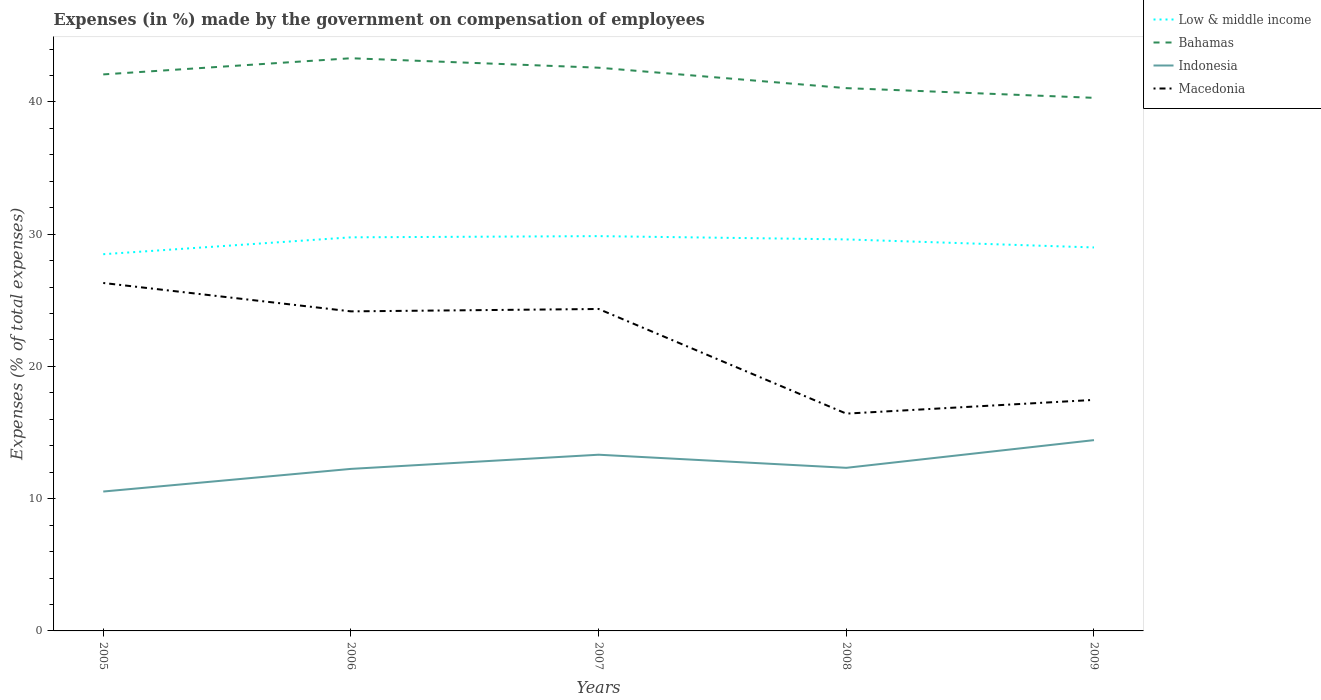How many different coloured lines are there?
Provide a short and direct response. 4. Does the line corresponding to Bahamas intersect with the line corresponding to Low & middle income?
Provide a short and direct response. No. Across all years, what is the maximum percentage of expenses made by the government on compensation of employees in Indonesia?
Provide a succinct answer. 10.54. In which year was the percentage of expenses made by the government on compensation of employees in Indonesia maximum?
Your response must be concise. 2005. What is the total percentage of expenses made by the government on compensation of employees in Macedonia in the graph?
Keep it short and to the point. 7.73. What is the difference between the highest and the second highest percentage of expenses made by the government on compensation of employees in Bahamas?
Provide a succinct answer. 2.99. What is the difference between the highest and the lowest percentage of expenses made by the government on compensation of employees in Low & middle income?
Provide a short and direct response. 3. Is the percentage of expenses made by the government on compensation of employees in Low & middle income strictly greater than the percentage of expenses made by the government on compensation of employees in Indonesia over the years?
Your answer should be compact. No. What is the difference between two consecutive major ticks on the Y-axis?
Keep it short and to the point. 10. Are the values on the major ticks of Y-axis written in scientific E-notation?
Offer a terse response. No. Where does the legend appear in the graph?
Provide a succinct answer. Top right. How many legend labels are there?
Your answer should be compact. 4. How are the legend labels stacked?
Provide a succinct answer. Vertical. What is the title of the graph?
Make the answer very short. Expenses (in %) made by the government on compensation of employees. Does "Paraguay" appear as one of the legend labels in the graph?
Your answer should be very brief. No. What is the label or title of the Y-axis?
Provide a short and direct response. Expenses (% of total expenses). What is the Expenses (% of total expenses) in Low & middle income in 2005?
Your response must be concise. 28.48. What is the Expenses (% of total expenses) in Bahamas in 2005?
Give a very brief answer. 42.08. What is the Expenses (% of total expenses) of Indonesia in 2005?
Keep it short and to the point. 10.54. What is the Expenses (% of total expenses) in Macedonia in 2005?
Offer a very short reply. 26.31. What is the Expenses (% of total expenses) of Low & middle income in 2006?
Give a very brief answer. 29.76. What is the Expenses (% of total expenses) of Bahamas in 2006?
Offer a terse response. 43.3. What is the Expenses (% of total expenses) in Indonesia in 2006?
Make the answer very short. 12.25. What is the Expenses (% of total expenses) in Macedonia in 2006?
Your response must be concise. 24.16. What is the Expenses (% of total expenses) in Low & middle income in 2007?
Ensure brevity in your answer.  29.85. What is the Expenses (% of total expenses) of Bahamas in 2007?
Your response must be concise. 42.59. What is the Expenses (% of total expenses) of Indonesia in 2007?
Ensure brevity in your answer.  13.32. What is the Expenses (% of total expenses) of Macedonia in 2007?
Offer a very short reply. 24.34. What is the Expenses (% of total expenses) of Low & middle income in 2008?
Your answer should be very brief. 29.6. What is the Expenses (% of total expenses) of Bahamas in 2008?
Give a very brief answer. 41.04. What is the Expenses (% of total expenses) of Indonesia in 2008?
Provide a short and direct response. 12.33. What is the Expenses (% of total expenses) in Macedonia in 2008?
Make the answer very short. 16.43. What is the Expenses (% of total expenses) of Low & middle income in 2009?
Keep it short and to the point. 29. What is the Expenses (% of total expenses) of Bahamas in 2009?
Ensure brevity in your answer.  40.31. What is the Expenses (% of total expenses) in Indonesia in 2009?
Offer a terse response. 14.43. What is the Expenses (% of total expenses) of Macedonia in 2009?
Ensure brevity in your answer.  17.47. Across all years, what is the maximum Expenses (% of total expenses) of Low & middle income?
Provide a succinct answer. 29.85. Across all years, what is the maximum Expenses (% of total expenses) of Bahamas?
Keep it short and to the point. 43.3. Across all years, what is the maximum Expenses (% of total expenses) in Indonesia?
Your answer should be compact. 14.43. Across all years, what is the maximum Expenses (% of total expenses) in Macedonia?
Your answer should be very brief. 26.31. Across all years, what is the minimum Expenses (% of total expenses) in Low & middle income?
Your response must be concise. 28.48. Across all years, what is the minimum Expenses (% of total expenses) of Bahamas?
Ensure brevity in your answer.  40.31. Across all years, what is the minimum Expenses (% of total expenses) in Indonesia?
Offer a very short reply. 10.54. Across all years, what is the minimum Expenses (% of total expenses) of Macedonia?
Your response must be concise. 16.43. What is the total Expenses (% of total expenses) of Low & middle income in the graph?
Offer a very short reply. 146.7. What is the total Expenses (% of total expenses) in Bahamas in the graph?
Make the answer very short. 209.32. What is the total Expenses (% of total expenses) of Indonesia in the graph?
Provide a succinct answer. 62.87. What is the total Expenses (% of total expenses) of Macedonia in the graph?
Make the answer very short. 108.72. What is the difference between the Expenses (% of total expenses) in Low & middle income in 2005 and that in 2006?
Provide a succinct answer. -1.28. What is the difference between the Expenses (% of total expenses) of Bahamas in 2005 and that in 2006?
Keep it short and to the point. -1.22. What is the difference between the Expenses (% of total expenses) of Indonesia in 2005 and that in 2006?
Your answer should be very brief. -1.71. What is the difference between the Expenses (% of total expenses) in Macedonia in 2005 and that in 2006?
Make the answer very short. 2.15. What is the difference between the Expenses (% of total expenses) of Low & middle income in 2005 and that in 2007?
Your answer should be compact. -1.37. What is the difference between the Expenses (% of total expenses) of Bahamas in 2005 and that in 2007?
Make the answer very short. -0.51. What is the difference between the Expenses (% of total expenses) in Indonesia in 2005 and that in 2007?
Keep it short and to the point. -2.78. What is the difference between the Expenses (% of total expenses) in Macedonia in 2005 and that in 2007?
Offer a very short reply. 1.97. What is the difference between the Expenses (% of total expenses) in Low & middle income in 2005 and that in 2008?
Provide a short and direct response. -1.12. What is the difference between the Expenses (% of total expenses) of Bahamas in 2005 and that in 2008?
Provide a short and direct response. 1.04. What is the difference between the Expenses (% of total expenses) in Indonesia in 2005 and that in 2008?
Your answer should be very brief. -1.79. What is the difference between the Expenses (% of total expenses) of Macedonia in 2005 and that in 2008?
Offer a terse response. 9.88. What is the difference between the Expenses (% of total expenses) in Low & middle income in 2005 and that in 2009?
Provide a succinct answer. -0.51. What is the difference between the Expenses (% of total expenses) in Bahamas in 2005 and that in 2009?
Keep it short and to the point. 1.77. What is the difference between the Expenses (% of total expenses) of Indonesia in 2005 and that in 2009?
Offer a very short reply. -3.89. What is the difference between the Expenses (% of total expenses) in Macedonia in 2005 and that in 2009?
Offer a terse response. 8.84. What is the difference between the Expenses (% of total expenses) in Low & middle income in 2006 and that in 2007?
Provide a succinct answer. -0.09. What is the difference between the Expenses (% of total expenses) in Bahamas in 2006 and that in 2007?
Make the answer very short. 0.72. What is the difference between the Expenses (% of total expenses) of Indonesia in 2006 and that in 2007?
Ensure brevity in your answer.  -1.07. What is the difference between the Expenses (% of total expenses) in Macedonia in 2006 and that in 2007?
Keep it short and to the point. -0.18. What is the difference between the Expenses (% of total expenses) in Low & middle income in 2006 and that in 2008?
Your response must be concise. 0.16. What is the difference between the Expenses (% of total expenses) in Bahamas in 2006 and that in 2008?
Your answer should be compact. 2.26. What is the difference between the Expenses (% of total expenses) in Indonesia in 2006 and that in 2008?
Give a very brief answer. -0.08. What is the difference between the Expenses (% of total expenses) of Macedonia in 2006 and that in 2008?
Keep it short and to the point. 7.73. What is the difference between the Expenses (% of total expenses) in Low & middle income in 2006 and that in 2009?
Offer a very short reply. 0.77. What is the difference between the Expenses (% of total expenses) in Bahamas in 2006 and that in 2009?
Your answer should be compact. 2.99. What is the difference between the Expenses (% of total expenses) in Indonesia in 2006 and that in 2009?
Offer a terse response. -2.18. What is the difference between the Expenses (% of total expenses) of Macedonia in 2006 and that in 2009?
Provide a succinct answer. 6.69. What is the difference between the Expenses (% of total expenses) in Low & middle income in 2007 and that in 2008?
Your answer should be very brief. 0.25. What is the difference between the Expenses (% of total expenses) of Bahamas in 2007 and that in 2008?
Provide a short and direct response. 1.55. What is the difference between the Expenses (% of total expenses) in Macedonia in 2007 and that in 2008?
Provide a succinct answer. 7.91. What is the difference between the Expenses (% of total expenses) in Low & middle income in 2007 and that in 2009?
Make the answer very short. 0.86. What is the difference between the Expenses (% of total expenses) in Bahamas in 2007 and that in 2009?
Provide a succinct answer. 2.28. What is the difference between the Expenses (% of total expenses) in Indonesia in 2007 and that in 2009?
Offer a very short reply. -1.1. What is the difference between the Expenses (% of total expenses) of Macedonia in 2007 and that in 2009?
Offer a very short reply. 6.87. What is the difference between the Expenses (% of total expenses) in Low & middle income in 2008 and that in 2009?
Make the answer very short. 0.61. What is the difference between the Expenses (% of total expenses) of Bahamas in 2008 and that in 2009?
Provide a short and direct response. 0.73. What is the difference between the Expenses (% of total expenses) in Indonesia in 2008 and that in 2009?
Ensure brevity in your answer.  -2.09. What is the difference between the Expenses (% of total expenses) in Macedonia in 2008 and that in 2009?
Your response must be concise. -1.04. What is the difference between the Expenses (% of total expenses) in Low & middle income in 2005 and the Expenses (% of total expenses) in Bahamas in 2006?
Offer a very short reply. -14.82. What is the difference between the Expenses (% of total expenses) in Low & middle income in 2005 and the Expenses (% of total expenses) in Indonesia in 2006?
Provide a short and direct response. 16.23. What is the difference between the Expenses (% of total expenses) in Low & middle income in 2005 and the Expenses (% of total expenses) in Macedonia in 2006?
Keep it short and to the point. 4.32. What is the difference between the Expenses (% of total expenses) of Bahamas in 2005 and the Expenses (% of total expenses) of Indonesia in 2006?
Your answer should be compact. 29.83. What is the difference between the Expenses (% of total expenses) in Bahamas in 2005 and the Expenses (% of total expenses) in Macedonia in 2006?
Ensure brevity in your answer.  17.92. What is the difference between the Expenses (% of total expenses) in Indonesia in 2005 and the Expenses (% of total expenses) in Macedonia in 2006?
Ensure brevity in your answer.  -13.62. What is the difference between the Expenses (% of total expenses) in Low & middle income in 2005 and the Expenses (% of total expenses) in Bahamas in 2007?
Make the answer very short. -14.1. What is the difference between the Expenses (% of total expenses) in Low & middle income in 2005 and the Expenses (% of total expenses) in Indonesia in 2007?
Your answer should be compact. 15.16. What is the difference between the Expenses (% of total expenses) of Low & middle income in 2005 and the Expenses (% of total expenses) of Macedonia in 2007?
Your answer should be compact. 4.14. What is the difference between the Expenses (% of total expenses) of Bahamas in 2005 and the Expenses (% of total expenses) of Indonesia in 2007?
Your answer should be very brief. 28.76. What is the difference between the Expenses (% of total expenses) in Bahamas in 2005 and the Expenses (% of total expenses) in Macedonia in 2007?
Give a very brief answer. 17.74. What is the difference between the Expenses (% of total expenses) of Indonesia in 2005 and the Expenses (% of total expenses) of Macedonia in 2007?
Your response must be concise. -13.8. What is the difference between the Expenses (% of total expenses) of Low & middle income in 2005 and the Expenses (% of total expenses) of Bahamas in 2008?
Provide a short and direct response. -12.56. What is the difference between the Expenses (% of total expenses) of Low & middle income in 2005 and the Expenses (% of total expenses) of Indonesia in 2008?
Your answer should be compact. 16.15. What is the difference between the Expenses (% of total expenses) in Low & middle income in 2005 and the Expenses (% of total expenses) in Macedonia in 2008?
Keep it short and to the point. 12.05. What is the difference between the Expenses (% of total expenses) in Bahamas in 2005 and the Expenses (% of total expenses) in Indonesia in 2008?
Your response must be concise. 29.75. What is the difference between the Expenses (% of total expenses) of Bahamas in 2005 and the Expenses (% of total expenses) of Macedonia in 2008?
Keep it short and to the point. 25.65. What is the difference between the Expenses (% of total expenses) in Indonesia in 2005 and the Expenses (% of total expenses) in Macedonia in 2008?
Provide a succinct answer. -5.89. What is the difference between the Expenses (% of total expenses) in Low & middle income in 2005 and the Expenses (% of total expenses) in Bahamas in 2009?
Your answer should be very brief. -11.82. What is the difference between the Expenses (% of total expenses) in Low & middle income in 2005 and the Expenses (% of total expenses) in Indonesia in 2009?
Your response must be concise. 14.06. What is the difference between the Expenses (% of total expenses) in Low & middle income in 2005 and the Expenses (% of total expenses) in Macedonia in 2009?
Make the answer very short. 11.02. What is the difference between the Expenses (% of total expenses) of Bahamas in 2005 and the Expenses (% of total expenses) of Indonesia in 2009?
Make the answer very short. 27.65. What is the difference between the Expenses (% of total expenses) of Bahamas in 2005 and the Expenses (% of total expenses) of Macedonia in 2009?
Offer a terse response. 24.61. What is the difference between the Expenses (% of total expenses) in Indonesia in 2005 and the Expenses (% of total expenses) in Macedonia in 2009?
Give a very brief answer. -6.93. What is the difference between the Expenses (% of total expenses) in Low & middle income in 2006 and the Expenses (% of total expenses) in Bahamas in 2007?
Give a very brief answer. -12.83. What is the difference between the Expenses (% of total expenses) in Low & middle income in 2006 and the Expenses (% of total expenses) in Indonesia in 2007?
Your answer should be compact. 16.44. What is the difference between the Expenses (% of total expenses) of Low & middle income in 2006 and the Expenses (% of total expenses) of Macedonia in 2007?
Offer a very short reply. 5.42. What is the difference between the Expenses (% of total expenses) in Bahamas in 2006 and the Expenses (% of total expenses) in Indonesia in 2007?
Your answer should be very brief. 29.98. What is the difference between the Expenses (% of total expenses) in Bahamas in 2006 and the Expenses (% of total expenses) in Macedonia in 2007?
Provide a succinct answer. 18.96. What is the difference between the Expenses (% of total expenses) in Indonesia in 2006 and the Expenses (% of total expenses) in Macedonia in 2007?
Your answer should be very brief. -12.09. What is the difference between the Expenses (% of total expenses) of Low & middle income in 2006 and the Expenses (% of total expenses) of Bahamas in 2008?
Offer a terse response. -11.28. What is the difference between the Expenses (% of total expenses) of Low & middle income in 2006 and the Expenses (% of total expenses) of Indonesia in 2008?
Provide a short and direct response. 17.43. What is the difference between the Expenses (% of total expenses) of Low & middle income in 2006 and the Expenses (% of total expenses) of Macedonia in 2008?
Provide a short and direct response. 13.33. What is the difference between the Expenses (% of total expenses) of Bahamas in 2006 and the Expenses (% of total expenses) of Indonesia in 2008?
Provide a short and direct response. 30.97. What is the difference between the Expenses (% of total expenses) of Bahamas in 2006 and the Expenses (% of total expenses) of Macedonia in 2008?
Provide a short and direct response. 26.87. What is the difference between the Expenses (% of total expenses) in Indonesia in 2006 and the Expenses (% of total expenses) in Macedonia in 2008?
Your answer should be very brief. -4.18. What is the difference between the Expenses (% of total expenses) in Low & middle income in 2006 and the Expenses (% of total expenses) in Bahamas in 2009?
Give a very brief answer. -10.55. What is the difference between the Expenses (% of total expenses) in Low & middle income in 2006 and the Expenses (% of total expenses) in Indonesia in 2009?
Offer a terse response. 15.33. What is the difference between the Expenses (% of total expenses) in Low & middle income in 2006 and the Expenses (% of total expenses) in Macedonia in 2009?
Offer a terse response. 12.29. What is the difference between the Expenses (% of total expenses) of Bahamas in 2006 and the Expenses (% of total expenses) of Indonesia in 2009?
Offer a terse response. 28.88. What is the difference between the Expenses (% of total expenses) in Bahamas in 2006 and the Expenses (% of total expenses) in Macedonia in 2009?
Give a very brief answer. 25.83. What is the difference between the Expenses (% of total expenses) of Indonesia in 2006 and the Expenses (% of total expenses) of Macedonia in 2009?
Give a very brief answer. -5.22. What is the difference between the Expenses (% of total expenses) in Low & middle income in 2007 and the Expenses (% of total expenses) in Bahamas in 2008?
Provide a succinct answer. -11.19. What is the difference between the Expenses (% of total expenses) of Low & middle income in 2007 and the Expenses (% of total expenses) of Indonesia in 2008?
Provide a short and direct response. 17.52. What is the difference between the Expenses (% of total expenses) in Low & middle income in 2007 and the Expenses (% of total expenses) in Macedonia in 2008?
Keep it short and to the point. 13.42. What is the difference between the Expenses (% of total expenses) of Bahamas in 2007 and the Expenses (% of total expenses) of Indonesia in 2008?
Offer a very short reply. 30.25. What is the difference between the Expenses (% of total expenses) of Bahamas in 2007 and the Expenses (% of total expenses) of Macedonia in 2008?
Give a very brief answer. 26.16. What is the difference between the Expenses (% of total expenses) in Indonesia in 2007 and the Expenses (% of total expenses) in Macedonia in 2008?
Make the answer very short. -3.11. What is the difference between the Expenses (% of total expenses) in Low & middle income in 2007 and the Expenses (% of total expenses) in Bahamas in 2009?
Provide a succinct answer. -10.46. What is the difference between the Expenses (% of total expenses) of Low & middle income in 2007 and the Expenses (% of total expenses) of Indonesia in 2009?
Give a very brief answer. 15.42. What is the difference between the Expenses (% of total expenses) of Low & middle income in 2007 and the Expenses (% of total expenses) of Macedonia in 2009?
Provide a succinct answer. 12.38. What is the difference between the Expenses (% of total expenses) in Bahamas in 2007 and the Expenses (% of total expenses) in Indonesia in 2009?
Keep it short and to the point. 28.16. What is the difference between the Expenses (% of total expenses) in Bahamas in 2007 and the Expenses (% of total expenses) in Macedonia in 2009?
Give a very brief answer. 25.12. What is the difference between the Expenses (% of total expenses) in Indonesia in 2007 and the Expenses (% of total expenses) in Macedonia in 2009?
Provide a succinct answer. -4.15. What is the difference between the Expenses (% of total expenses) in Low & middle income in 2008 and the Expenses (% of total expenses) in Bahamas in 2009?
Your answer should be compact. -10.71. What is the difference between the Expenses (% of total expenses) of Low & middle income in 2008 and the Expenses (% of total expenses) of Indonesia in 2009?
Offer a terse response. 15.18. What is the difference between the Expenses (% of total expenses) in Low & middle income in 2008 and the Expenses (% of total expenses) in Macedonia in 2009?
Keep it short and to the point. 12.14. What is the difference between the Expenses (% of total expenses) in Bahamas in 2008 and the Expenses (% of total expenses) in Indonesia in 2009?
Provide a succinct answer. 26.62. What is the difference between the Expenses (% of total expenses) in Bahamas in 2008 and the Expenses (% of total expenses) in Macedonia in 2009?
Your answer should be compact. 23.57. What is the difference between the Expenses (% of total expenses) of Indonesia in 2008 and the Expenses (% of total expenses) of Macedonia in 2009?
Provide a succinct answer. -5.14. What is the average Expenses (% of total expenses) of Low & middle income per year?
Offer a very short reply. 29.34. What is the average Expenses (% of total expenses) of Bahamas per year?
Provide a short and direct response. 41.86. What is the average Expenses (% of total expenses) in Indonesia per year?
Give a very brief answer. 12.57. What is the average Expenses (% of total expenses) in Macedonia per year?
Provide a succinct answer. 21.74. In the year 2005, what is the difference between the Expenses (% of total expenses) in Low & middle income and Expenses (% of total expenses) in Bahamas?
Provide a short and direct response. -13.6. In the year 2005, what is the difference between the Expenses (% of total expenses) of Low & middle income and Expenses (% of total expenses) of Indonesia?
Ensure brevity in your answer.  17.95. In the year 2005, what is the difference between the Expenses (% of total expenses) in Low & middle income and Expenses (% of total expenses) in Macedonia?
Your answer should be compact. 2.18. In the year 2005, what is the difference between the Expenses (% of total expenses) in Bahamas and Expenses (% of total expenses) in Indonesia?
Your answer should be very brief. 31.54. In the year 2005, what is the difference between the Expenses (% of total expenses) in Bahamas and Expenses (% of total expenses) in Macedonia?
Your response must be concise. 15.77. In the year 2005, what is the difference between the Expenses (% of total expenses) of Indonesia and Expenses (% of total expenses) of Macedonia?
Offer a terse response. -15.77. In the year 2006, what is the difference between the Expenses (% of total expenses) of Low & middle income and Expenses (% of total expenses) of Bahamas?
Your response must be concise. -13.54. In the year 2006, what is the difference between the Expenses (% of total expenses) in Low & middle income and Expenses (% of total expenses) in Indonesia?
Make the answer very short. 17.51. In the year 2006, what is the difference between the Expenses (% of total expenses) in Low & middle income and Expenses (% of total expenses) in Macedonia?
Keep it short and to the point. 5.6. In the year 2006, what is the difference between the Expenses (% of total expenses) of Bahamas and Expenses (% of total expenses) of Indonesia?
Your answer should be very brief. 31.05. In the year 2006, what is the difference between the Expenses (% of total expenses) in Bahamas and Expenses (% of total expenses) in Macedonia?
Offer a terse response. 19.14. In the year 2006, what is the difference between the Expenses (% of total expenses) in Indonesia and Expenses (% of total expenses) in Macedonia?
Provide a short and direct response. -11.91. In the year 2007, what is the difference between the Expenses (% of total expenses) of Low & middle income and Expenses (% of total expenses) of Bahamas?
Provide a short and direct response. -12.74. In the year 2007, what is the difference between the Expenses (% of total expenses) in Low & middle income and Expenses (% of total expenses) in Indonesia?
Your response must be concise. 16.53. In the year 2007, what is the difference between the Expenses (% of total expenses) of Low & middle income and Expenses (% of total expenses) of Macedonia?
Keep it short and to the point. 5.51. In the year 2007, what is the difference between the Expenses (% of total expenses) in Bahamas and Expenses (% of total expenses) in Indonesia?
Provide a succinct answer. 29.26. In the year 2007, what is the difference between the Expenses (% of total expenses) in Bahamas and Expenses (% of total expenses) in Macedonia?
Make the answer very short. 18.25. In the year 2007, what is the difference between the Expenses (% of total expenses) of Indonesia and Expenses (% of total expenses) of Macedonia?
Give a very brief answer. -11.02. In the year 2008, what is the difference between the Expenses (% of total expenses) of Low & middle income and Expenses (% of total expenses) of Bahamas?
Provide a succinct answer. -11.44. In the year 2008, what is the difference between the Expenses (% of total expenses) in Low & middle income and Expenses (% of total expenses) in Indonesia?
Give a very brief answer. 17.27. In the year 2008, what is the difference between the Expenses (% of total expenses) of Low & middle income and Expenses (% of total expenses) of Macedonia?
Provide a short and direct response. 13.17. In the year 2008, what is the difference between the Expenses (% of total expenses) of Bahamas and Expenses (% of total expenses) of Indonesia?
Give a very brief answer. 28.71. In the year 2008, what is the difference between the Expenses (% of total expenses) in Bahamas and Expenses (% of total expenses) in Macedonia?
Your response must be concise. 24.61. In the year 2008, what is the difference between the Expenses (% of total expenses) in Indonesia and Expenses (% of total expenses) in Macedonia?
Offer a very short reply. -4.1. In the year 2009, what is the difference between the Expenses (% of total expenses) in Low & middle income and Expenses (% of total expenses) in Bahamas?
Offer a very short reply. -11.31. In the year 2009, what is the difference between the Expenses (% of total expenses) in Low & middle income and Expenses (% of total expenses) in Indonesia?
Your answer should be compact. 14.57. In the year 2009, what is the difference between the Expenses (% of total expenses) in Low & middle income and Expenses (% of total expenses) in Macedonia?
Your answer should be very brief. 11.53. In the year 2009, what is the difference between the Expenses (% of total expenses) of Bahamas and Expenses (% of total expenses) of Indonesia?
Your answer should be compact. 25.88. In the year 2009, what is the difference between the Expenses (% of total expenses) in Bahamas and Expenses (% of total expenses) in Macedonia?
Provide a short and direct response. 22.84. In the year 2009, what is the difference between the Expenses (% of total expenses) of Indonesia and Expenses (% of total expenses) of Macedonia?
Make the answer very short. -3.04. What is the ratio of the Expenses (% of total expenses) in Low & middle income in 2005 to that in 2006?
Your answer should be very brief. 0.96. What is the ratio of the Expenses (% of total expenses) in Bahamas in 2005 to that in 2006?
Provide a short and direct response. 0.97. What is the ratio of the Expenses (% of total expenses) in Indonesia in 2005 to that in 2006?
Offer a very short reply. 0.86. What is the ratio of the Expenses (% of total expenses) in Macedonia in 2005 to that in 2006?
Give a very brief answer. 1.09. What is the ratio of the Expenses (% of total expenses) of Low & middle income in 2005 to that in 2007?
Your response must be concise. 0.95. What is the ratio of the Expenses (% of total expenses) of Indonesia in 2005 to that in 2007?
Provide a succinct answer. 0.79. What is the ratio of the Expenses (% of total expenses) of Macedonia in 2005 to that in 2007?
Give a very brief answer. 1.08. What is the ratio of the Expenses (% of total expenses) of Low & middle income in 2005 to that in 2008?
Your answer should be compact. 0.96. What is the ratio of the Expenses (% of total expenses) in Bahamas in 2005 to that in 2008?
Offer a terse response. 1.03. What is the ratio of the Expenses (% of total expenses) in Indonesia in 2005 to that in 2008?
Offer a terse response. 0.85. What is the ratio of the Expenses (% of total expenses) of Macedonia in 2005 to that in 2008?
Your response must be concise. 1.6. What is the ratio of the Expenses (% of total expenses) in Low & middle income in 2005 to that in 2009?
Offer a terse response. 0.98. What is the ratio of the Expenses (% of total expenses) in Bahamas in 2005 to that in 2009?
Ensure brevity in your answer.  1.04. What is the ratio of the Expenses (% of total expenses) of Indonesia in 2005 to that in 2009?
Keep it short and to the point. 0.73. What is the ratio of the Expenses (% of total expenses) in Macedonia in 2005 to that in 2009?
Offer a very short reply. 1.51. What is the ratio of the Expenses (% of total expenses) in Low & middle income in 2006 to that in 2007?
Ensure brevity in your answer.  1. What is the ratio of the Expenses (% of total expenses) of Bahamas in 2006 to that in 2007?
Your answer should be compact. 1.02. What is the ratio of the Expenses (% of total expenses) in Indonesia in 2006 to that in 2007?
Ensure brevity in your answer.  0.92. What is the ratio of the Expenses (% of total expenses) in Macedonia in 2006 to that in 2007?
Your answer should be compact. 0.99. What is the ratio of the Expenses (% of total expenses) in Bahamas in 2006 to that in 2008?
Make the answer very short. 1.06. What is the ratio of the Expenses (% of total expenses) in Macedonia in 2006 to that in 2008?
Provide a short and direct response. 1.47. What is the ratio of the Expenses (% of total expenses) of Low & middle income in 2006 to that in 2009?
Make the answer very short. 1.03. What is the ratio of the Expenses (% of total expenses) of Bahamas in 2006 to that in 2009?
Offer a terse response. 1.07. What is the ratio of the Expenses (% of total expenses) in Indonesia in 2006 to that in 2009?
Offer a very short reply. 0.85. What is the ratio of the Expenses (% of total expenses) in Macedonia in 2006 to that in 2009?
Provide a short and direct response. 1.38. What is the ratio of the Expenses (% of total expenses) of Low & middle income in 2007 to that in 2008?
Make the answer very short. 1.01. What is the ratio of the Expenses (% of total expenses) in Bahamas in 2007 to that in 2008?
Keep it short and to the point. 1.04. What is the ratio of the Expenses (% of total expenses) of Indonesia in 2007 to that in 2008?
Offer a very short reply. 1.08. What is the ratio of the Expenses (% of total expenses) of Macedonia in 2007 to that in 2008?
Ensure brevity in your answer.  1.48. What is the ratio of the Expenses (% of total expenses) of Low & middle income in 2007 to that in 2009?
Offer a very short reply. 1.03. What is the ratio of the Expenses (% of total expenses) in Bahamas in 2007 to that in 2009?
Provide a succinct answer. 1.06. What is the ratio of the Expenses (% of total expenses) of Indonesia in 2007 to that in 2009?
Give a very brief answer. 0.92. What is the ratio of the Expenses (% of total expenses) in Macedonia in 2007 to that in 2009?
Offer a terse response. 1.39. What is the ratio of the Expenses (% of total expenses) in Low & middle income in 2008 to that in 2009?
Give a very brief answer. 1.02. What is the ratio of the Expenses (% of total expenses) in Bahamas in 2008 to that in 2009?
Your answer should be compact. 1.02. What is the ratio of the Expenses (% of total expenses) in Indonesia in 2008 to that in 2009?
Provide a short and direct response. 0.85. What is the ratio of the Expenses (% of total expenses) of Macedonia in 2008 to that in 2009?
Offer a very short reply. 0.94. What is the difference between the highest and the second highest Expenses (% of total expenses) in Low & middle income?
Give a very brief answer. 0.09. What is the difference between the highest and the second highest Expenses (% of total expenses) in Bahamas?
Provide a succinct answer. 0.72. What is the difference between the highest and the second highest Expenses (% of total expenses) of Indonesia?
Provide a succinct answer. 1.1. What is the difference between the highest and the second highest Expenses (% of total expenses) in Macedonia?
Give a very brief answer. 1.97. What is the difference between the highest and the lowest Expenses (% of total expenses) of Low & middle income?
Provide a succinct answer. 1.37. What is the difference between the highest and the lowest Expenses (% of total expenses) of Bahamas?
Your answer should be very brief. 2.99. What is the difference between the highest and the lowest Expenses (% of total expenses) in Indonesia?
Your response must be concise. 3.89. What is the difference between the highest and the lowest Expenses (% of total expenses) in Macedonia?
Offer a terse response. 9.88. 